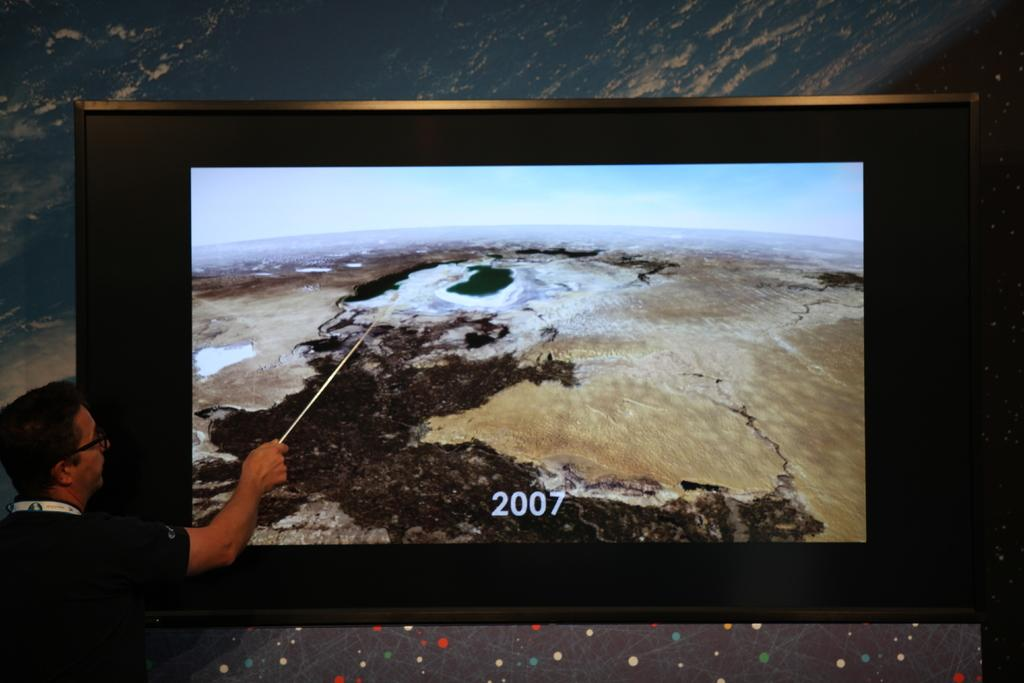<image>
Render a clear and concise summary of the photo. A man is pointing at a screen, which is labelled 2007. 